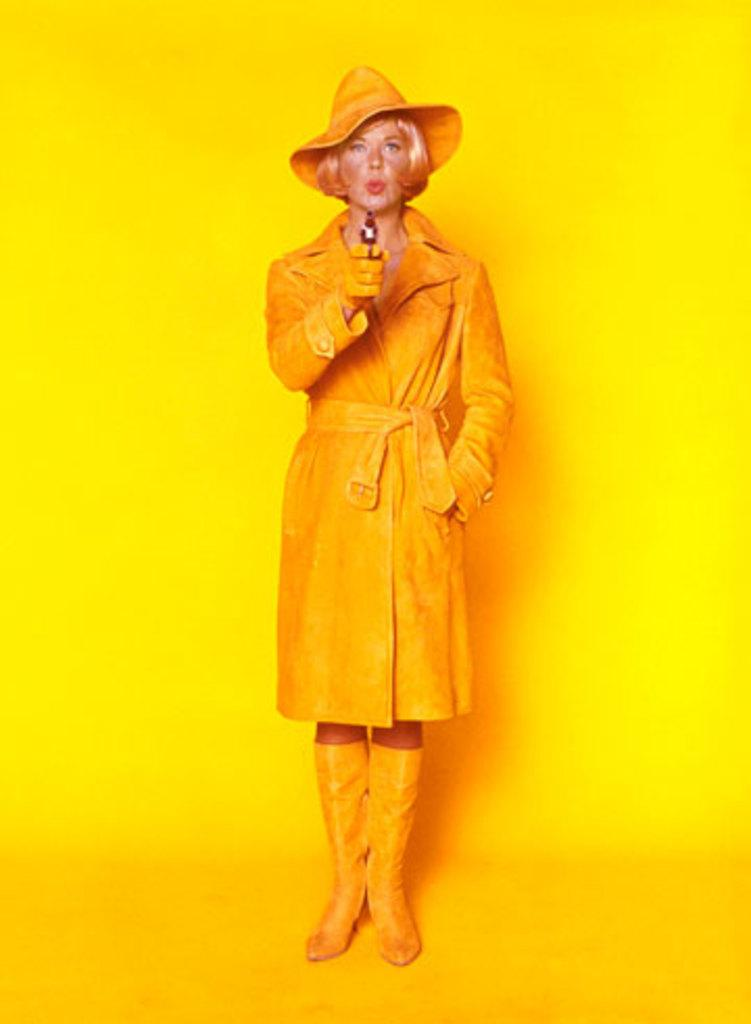Who is present in the image? There is a woman in the image. What is the woman wearing on her head? The woman is wearing a hat. What object is the woman holding in her hand? The woman is holding a gun in her hand. What is the woman standing on in the image? The woman is standing on the floor. What can be seen in the background of the image? There is a wall in the background of the image. What type of flowers is the woman watering in the image? There are no flowers present in the image; the woman is holding a gun. 